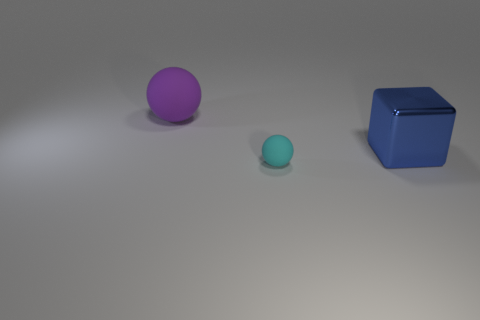Are there fewer big purple rubber balls than tiny red rubber things?
Your response must be concise. No. How many other objects are there of the same color as the small rubber thing?
Make the answer very short. 0. What number of blue rubber spheres are there?
Keep it short and to the point. 0. Is the number of purple rubber balls behind the small cyan sphere less than the number of rubber things?
Offer a very short reply. Yes. Do the large thing that is on the right side of the purple object and the cyan sphere have the same material?
Your answer should be compact. No. What shape is the thing that is left of the rubber thing that is in front of the big thing behind the big metallic cube?
Your response must be concise. Sphere. Is there a cyan matte thing that has the same size as the blue block?
Your answer should be compact. No. The blue metal object is what size?
Your answer should be compact. Large. What number of other cyan spheres are the same size as the cyan matte ball?
Offer a terse response. 0. Is the number of purple rubber objects that are right of the cyan matte thing less than the number of rubber things that are behind the blue metallic cube?
Make the answer very short. Yes. 